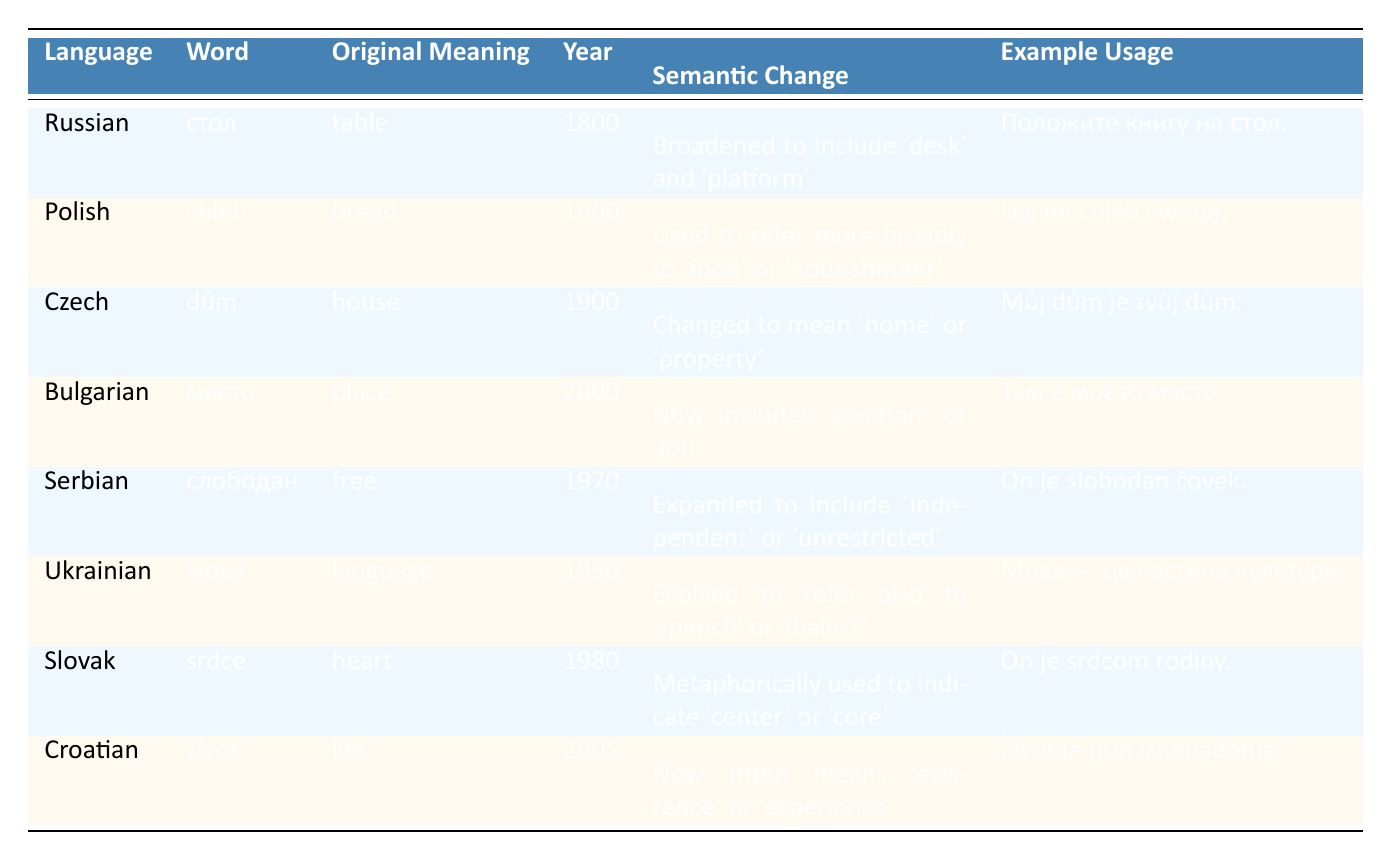What is the original meaning of the word "život" in Croatian? The table shows that the original meaning of "život" in Croatian is "life."
Answer: life Which language's core vocabulary word has undergone a semantic change to include the meaning "position" or "job"? Referring to the table, the Bulgarian word "място" originally meant "place" and has changed to include meanings of "position" or "job."
Answer: място Is it true that the semantic change of the word "слободан" in Serbian has narrowed its original meaning? The table indicates that the word "слободан" originally meant "free" and has expanded to also mean "independent" or "unrestricted," which means the change is broadening, not narrowing.
Answer: No What was the year when the word "dům" in Czech experienced its semantic change? The table states that the word "dům" in Czech had its semantic change in the year 1900.
Answer: 1900 How many words in the table have undergone a semantic change after the year 2000? From visual inspection of the table, the words "място" (Bulgarian) and "život" (Croatian) both underwent semantic changes after the year 2000, totaling two words.
Answer: 2 Which word in the table connects the semantic expansion of "food" or "nourishment"? The word "chleb" from the Polish language has expanded its original meaning of "bread" to cover "food" or "nourishment."
Answer: chleb What percentage of the words listed in the table involve semantic changes related to expanding meanings versus narrowing? Counting the words: 5 out of 8 words show an expansion in their meanings, while 3 have more specific meanings. Therefore, the percentage of words that expanded is (5/8) * 100 = 62.5%, and those that narrowed is (3/8) * 100 = 37.5%.
Answer: 62.5% expanded, 37.5% narrowed What is the example usage for the word "мова" in Ukrainian? The table provides the example usage for "мова" as "Мова — це частина культури." which translates to "Language is a part of culture."
Answer: Мова — це частина культури 